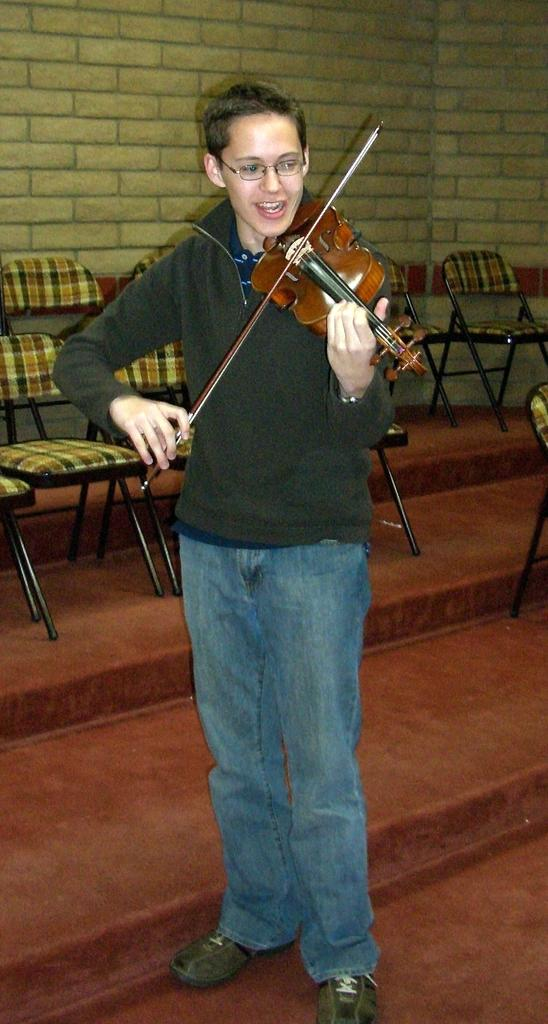Who is the main subject in the image? There is a boy in the image. What is the boy doing in the image? The boy is playing the violin. What type of furniture can be seen in the image? There are chairs in the image. Are there any architectural features visible in the image? Yes, there are stairs in the image. What is visible in the background of the image? A wall is visible in the background of the image. How many cakes are being served on the stairs in the image? There are no cakes present in the image; the boy is playing the violin, and there are chairs and stairs visible. What type of change is the boy experiencing while playing the violin in the image? There is no indication of any change happening to the boy while playing the violin in the image. 